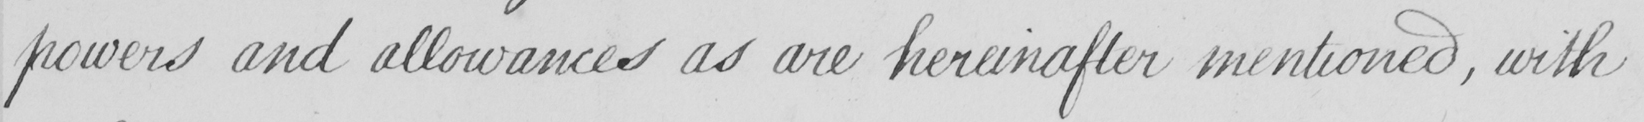What text is written in this handwritten line? powers and allowances as are hereinafter mentioned , with 